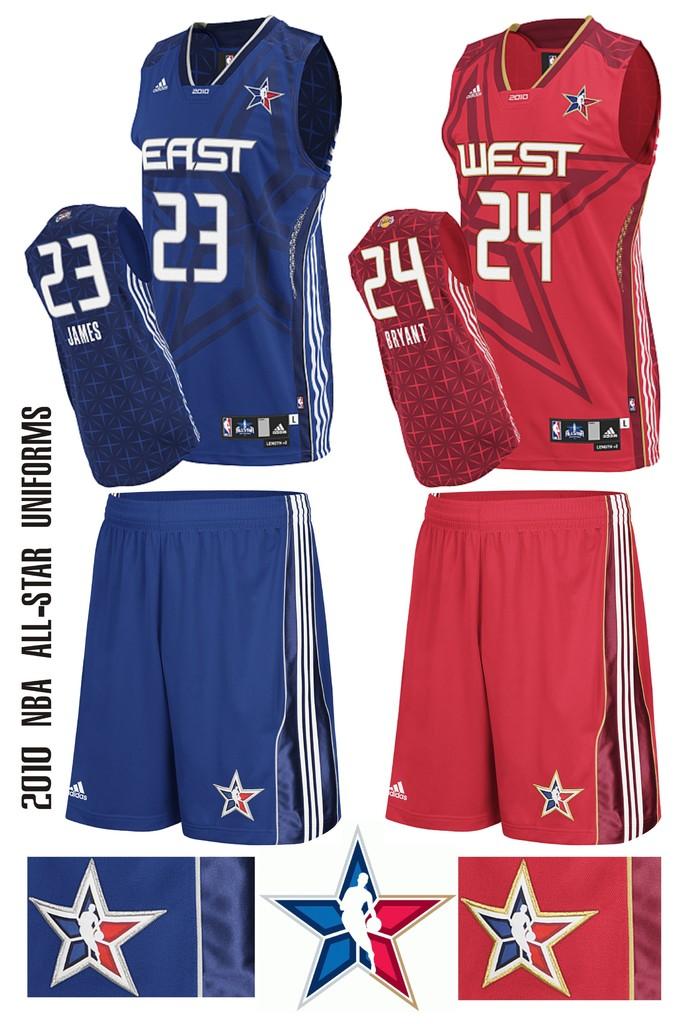What year were the uniforms used?
Your answer should be compact. 2010. Which number is east?
Offer a terse response. 23. 